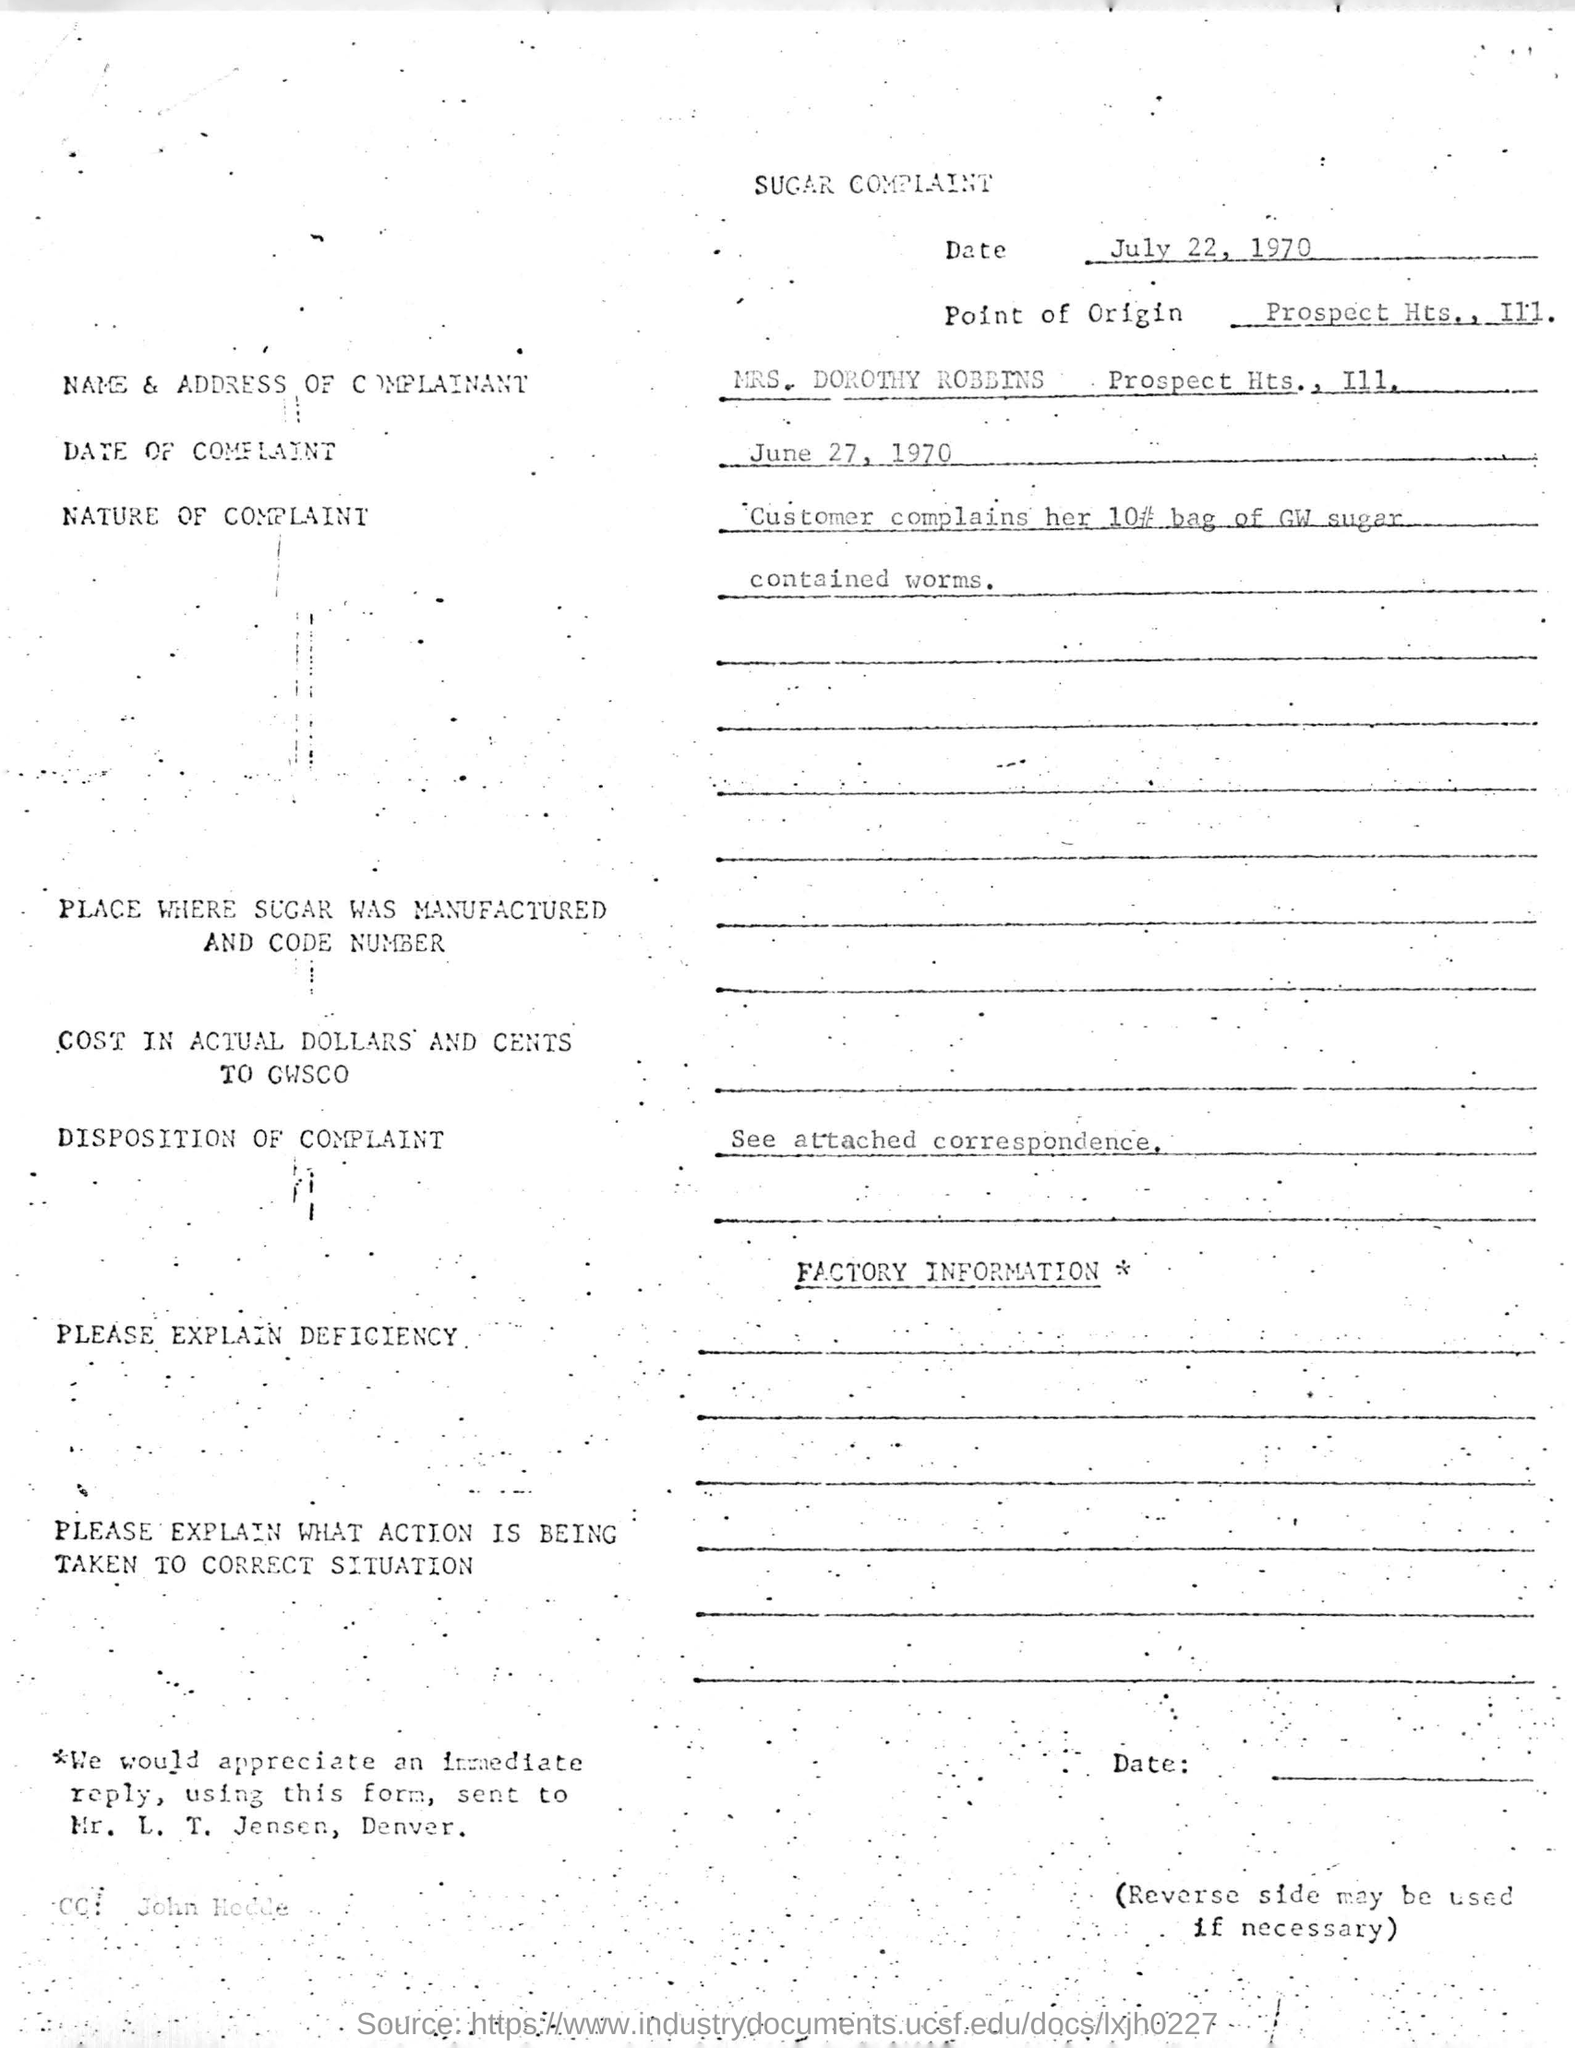When did the customer give the complaint?
Provide a short and direct response. June 27, 1970. Where is the point of origin of the complaint?
Provide a succinct answer. Prospect Hts., I11. What did the bag of GW sugar contain?
Your answer should be very brief. Worms. 